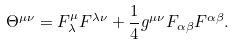<formula> <loc_0><loc_0><loc_500><loc_500>\Theta ^ { \mu \nu } = F _ { \lambda } ^ { \mu } F ^ { \lambda \nu } + \frac { 1 } { 4 } g ^ { \mu \nu } F _ { \alpha \beta } F ^ { \alpha \beta } .</formula> 